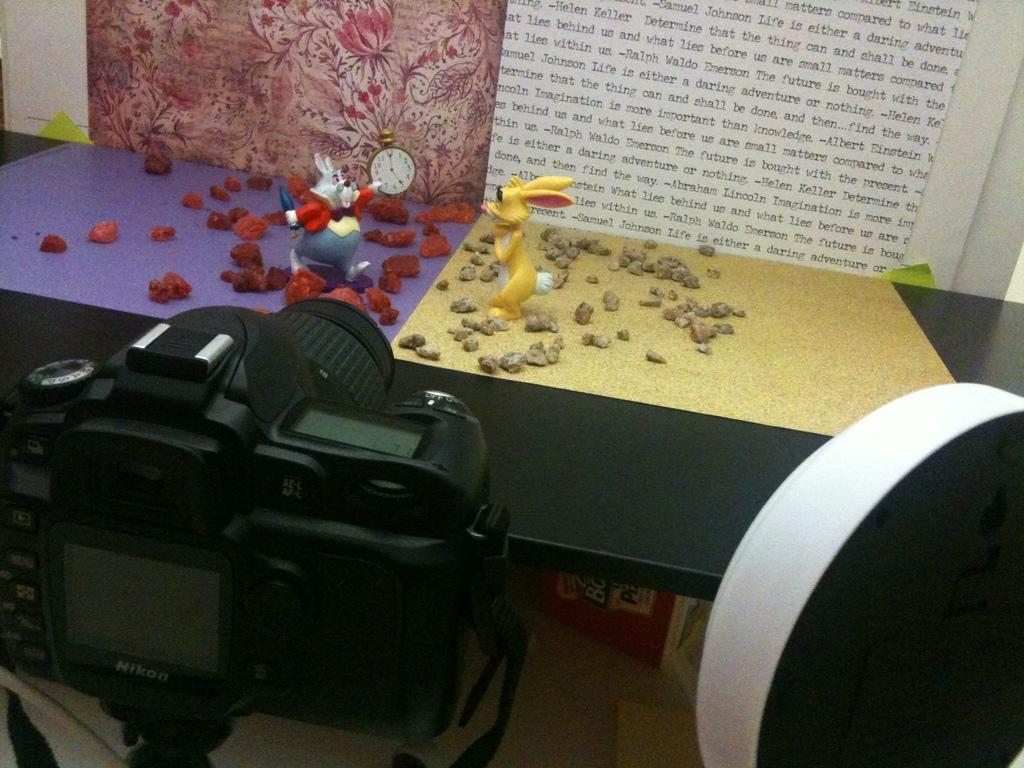How many toys can be seen in the image? There are two toys in the image. What else is present in the image besides the toys? There are stones, an alarm clock, a camera, an unspecified object, and papers stuck to the wall in the background. Where is the alarm clock located in the image? The alarm clock is on the table in the image. What is the unspecified object in the image? Unfortunately, the facts provided do not specify the nature of the unspecified object. What type of reading material is visible in the image? There is no reading material visible in the image. What is the relation between the stones and the camera in the image? There is no information provided about a relation between the stones and the camera in the image. 